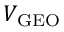<formula> <loc_0><loc_0><loc_500><loc_500>V _ { G E O }</formula> 